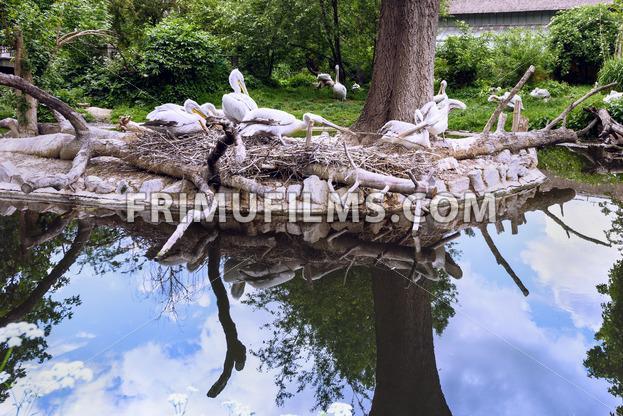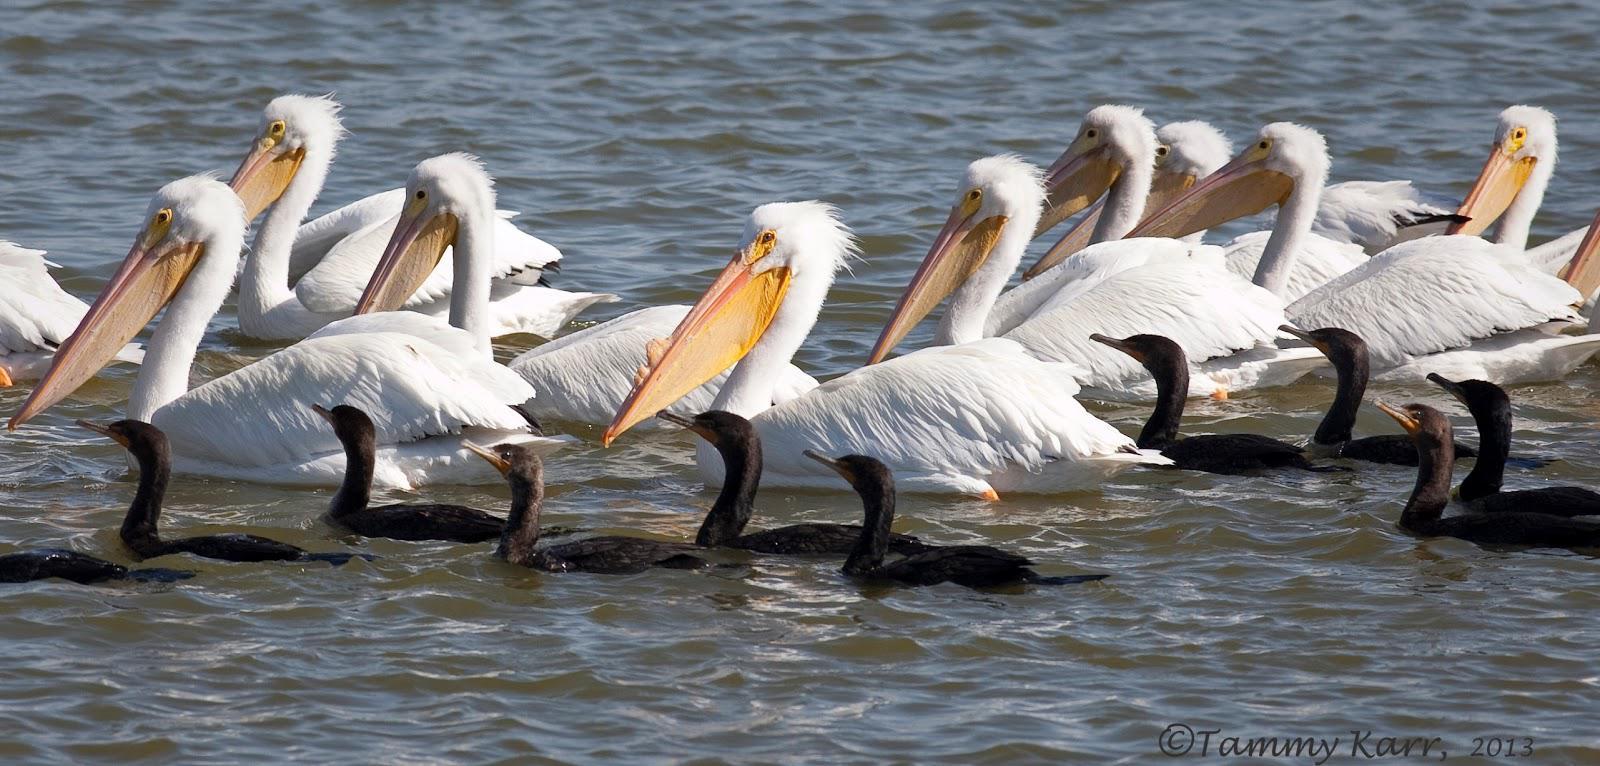The first image is the image on the left, the second image is the image on the right. For the images shown, is this caption "There are at most 5 birds in each image." true? Answer yes or no. No. The first image is the image on the left, the second image is the image on the right. Analyze the images presented: Is the assertion "Right image shows pelicans with smaller dark birds." valid? Answer yes or no. Yes. 